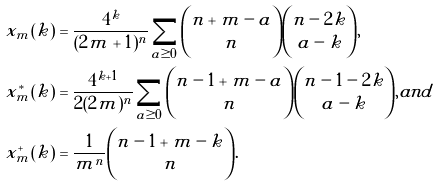<formula> <loc_0><loc_0><loc_500><loc_500>x _ { m } ( k ) & = \frac { 4 ^ { k } } { ( 2 m + 1 ) ^ { n } } \sum _ { a \geq 0 } \binom { n + m - a } { n } \binom { n - 2 k } { a - k } , \\ x _ { m } ^ { * } ( k ) & = \frac { 4 ^ { k + 1 } } { 2 ( 2 m ) ^ { n } } \sum _ { a \geq 0 } \binom { n - 1 + m - a } { n } \binom { n - 1 - 2 k } { a - k } , a n d \\ x _ { m } ^ { + } ( k ) & = \frac { 1 } { m ^ { n } } \binom { n - 1 + m - k } { n } .</formula> 